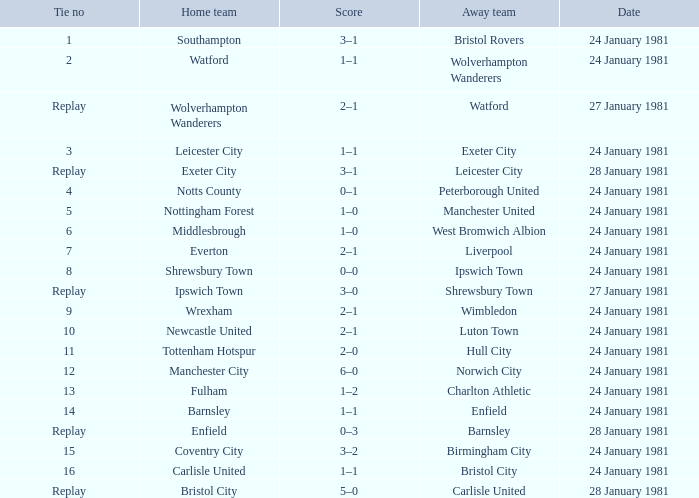What is the score when the tie is 8? 0–0. 